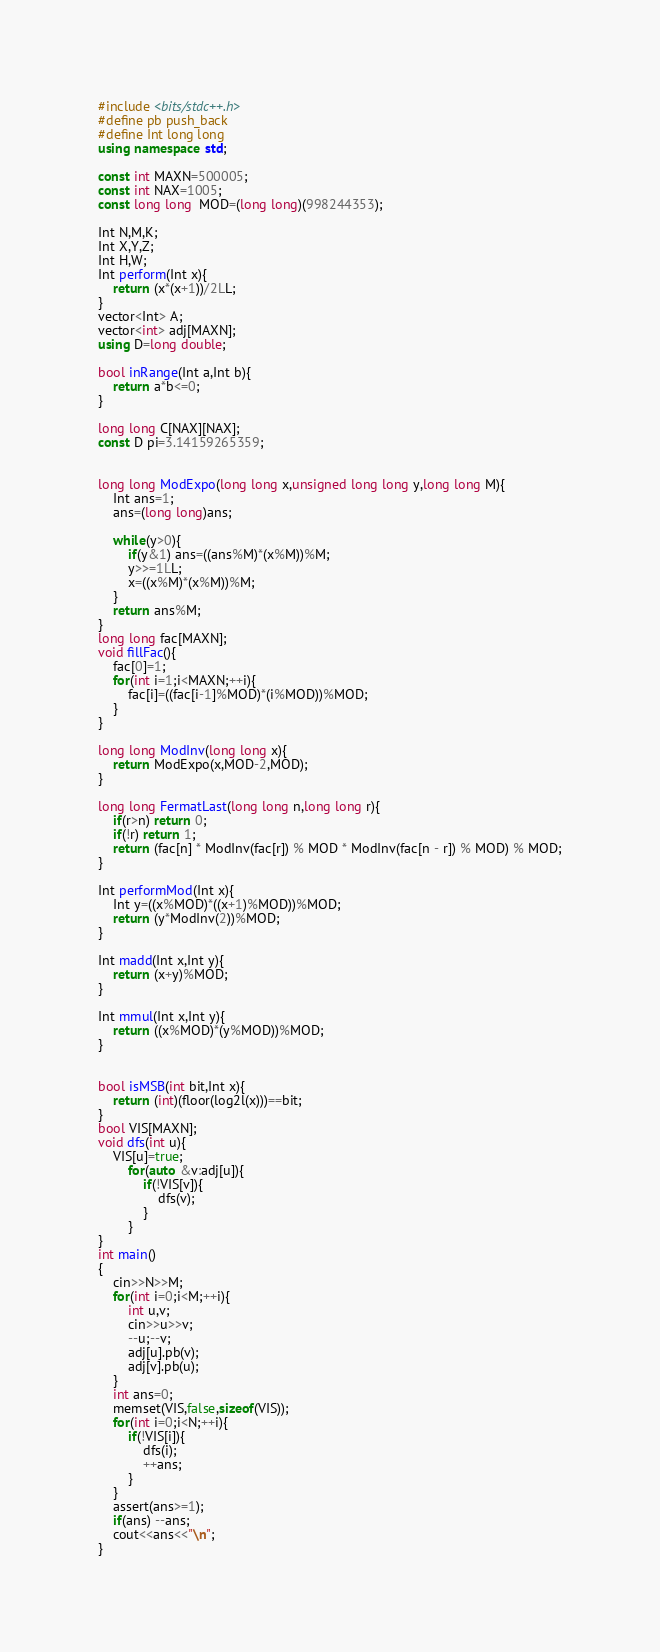Convert code to text. <code><loc_0><loc_0><loc_500><loc_500><_C++_>#include <bits/stdc++.h>
#define pb push_back
#define Int long long
using namespace std;

const int MAXN=500005;
const int NAX=1005;
const long long  MOD=(long long)(998244353);

Int N,M,K;
Int X,Y,Z;
Int H,W;
Int perform(Int x){
    return (x*(x+1))/2LL;
}
vector<Int> A;
vector<int> adj[MAXN];
using D=long double;

bool inRange(Int a,Int b){
    return a*b<=0;
}

long long C[NAX][NAX];
const D pi=3.14159265359;


long long ModExpo(long long x,unsigned long long y,long long M){
    Int ans=1;
    ans=(long long)ans;
    
    while(y>0){
        if(y&1) ans=((ans%M)*(x%M))%M;
        y>>=1LL;
        x=((x%M)*(x%M))%M;
    }
    return ans%M;
}
long long fac[MAXN];
void fillFac(){
    fac[0]=1;
    for(int i=1;i<MAXN;++i){
        fac[i]=((fac[i-1]%MOD)*(i%MOD))%MOD;
    }
}

long long ModInv(long long x){
    return ModExpo(x,MOD-2,MOD);
}

long long FermatLast(long long n,long long r){
    if(r>n) return 0;
    if(!r) return 1;
    return (fac[n] * ModInv(fac[r]) % MOD * ModInv(fac[n - r]) % MOD) % MOD;
}

Int performMod(Int x){
    Int y=((x%MOD)*((x+1)%MOD))%MOD;
    return (y*ModInv(2))%MOD;
}

Int madd(Int x,Int y){
    return (x+y)%MOD;
}

Int mmul(Int x,Int y){
    return ((x%MOD)*(y%MOD))%MOD;
}


bool isMSB(int bit,Int x){
    return (int)(floor(log2l(x)))==bit;
}
bool VIS[MAXN];
void dfs(int u){
    VIS[u]=true;
        for(auto &v:adj[u]){
            if(!VIS[v]){
                dfs(v);
            }
        }
}
int main()
{
    cin>>N>>M;
    for(int i=0;i<M;++i){
        int u,v;
        cin>>u>>v;
        --u;--v;
        adj[u].pb(v);
        adj[v].pb(u);
    }
    int ans=0;
    memset(VIS,false,sizeof(VIS));
    for(int i=0;i<N;++i){
        if(!VIS[i]){
            dfs(i);
            ++ans;
        }
    }
    assert(ans>=1);
    if(ans) --ans;
    cout<<ans<<"\n";
}
</code> 